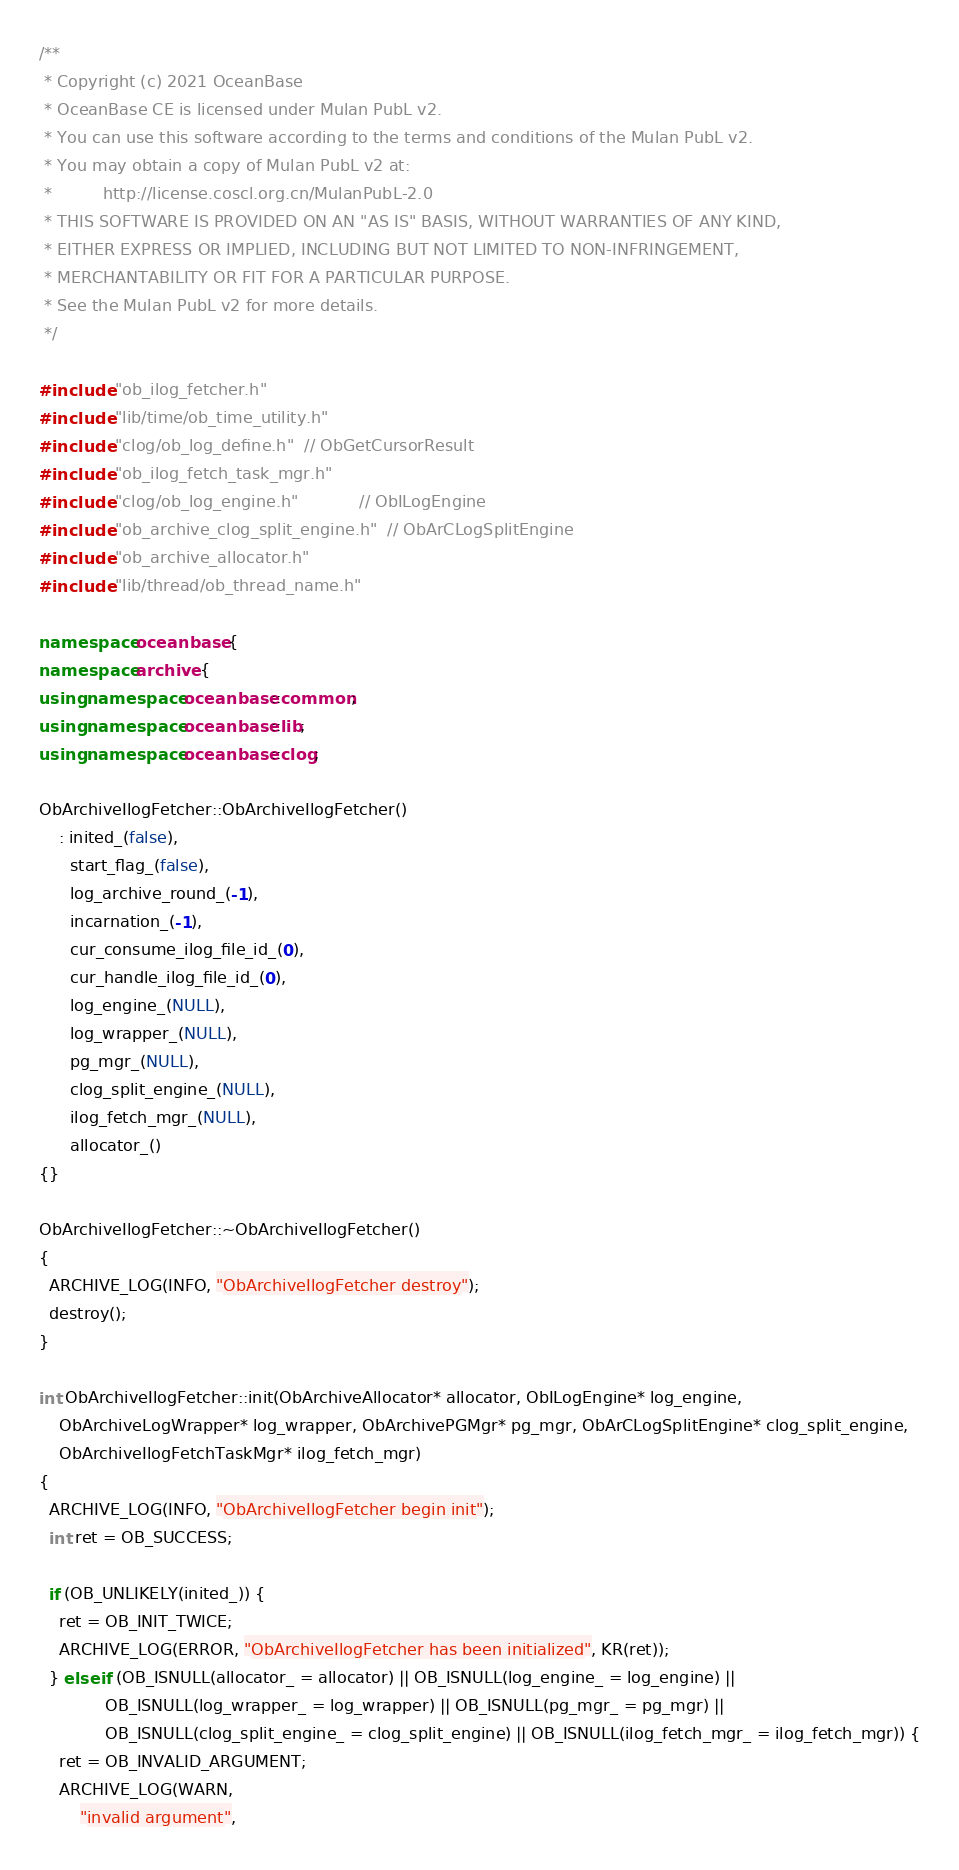Convert code to text. <code><loc_0><loc_0><loc_500><loc_500><_C++_>/**
 * Copyright (c) 2021 OceanBase
 * OceanBase CE is licensed under Mulan PubL v2.
 * You can use this software according to the terms and conditions of the Mulan PubL v2.
 * You may obtain a copy of Mulan PubL v2 at:
 *          http://license.coscl.org.cn/MulanPubL-2.0
 * THIS SOFTWARE IS PROVIDED ON AN "AS IS" BASIS, WITHOUT WARRANTIES OF ANY KIND,
 * EITHER EXPRESS OR IMPLIED, INCLUDING BUT NOT LIMITED TO NON-INFRINGEMENT,
 * MERCHANTABILITY OR FIT FOR A PARTICULAR PURPOSE.
 * See the Mulan PubL v2 for more details.
 */

#include "ob_ilog_fetcher.h"
#include "lib/time/ob_time_utility.h"
#include "clog/ob_log_define.h"  // ObGetCursorResult
#include "ob_ilog_fetch_task_mgr.h"
#include "clog/ob_log_engine.h"            // ObILogEngine
#include "ob_archive_clog_split_engine.h"  // ObArCLogSplitEngine
#include "ob_archive_allocator.h"
#include "lib/thread/ob_thread_name.h"

namespace oceanbase {
namespace archive {
using namespace oceanbase::common;
using namespace oceanbase::lib;
using namespace oceanbase::clog;

ObArchiveIlogFetcher::ObArchiveIlogFetcher()
    : inited_(false),
      start_flag_(false),
      log_archive_round_(-1),
      incarnation_(-1),
      cur_consume_ilog_file_id_(0),
      cur_handle_ilog_file_id_(0),
      log_engine_(NULL),
      log_wrapper_(NULL),
      pg_mgr_(NULL),
      clog_split_engine_(NULL),
      ilog_fetch_mgr_(NULL),
      allocator_()
{}

ObArchiveIlogFetcher::~ObArchiveIlogFetcher()
{
  ARCHIVE_LOG(INFO, "ObArchiveIlogFetcher destroy");
  destroy();
}

int ObArchiveIlogFetcher::init(ObArchiveAllocator* allocator, ObILogEngine* log_engine,
    ObArchiveLogWrapper* log_wrapper, ObArchivePGMgr* pg_mgr, ObArCLogSplitEngine* clog_split_engine,
    ObArchiveIlogFetchTaskMgr* ilog_fetch_mgr)
{
  ARCHIVE_LOG(INFO, "ObArchiveIlogFetcher begin init");
  int ret = OB_SUCCESS;

  if (OB_UNLIKELY(inited_)) {
    ret = OB_INIT_TWICE;
    ARCHIVE_LOG(ERROR, "ObArchiveIlogFetcher has been initialized", KR(ret));
  } else if (OB_ISNULL(allocator_ = allocator) || OB_ISNULL(log_engine_ = log_engine) ||
             OB_ISNULL(log_wrapper_ = log_wrapper) || OB_ISNULL(pg_mgr_ = pg_mgr) ||
             OB_ISNULL(clog_split_engine_ = clog_split_engine) || OB_ISNULL(ilog_fetch_mgr_ = ilog_fetch_mgr)) {
    ret = OB_INVALID_ARGUMENT;
    ARCHIVE_LOG(WARN,
        "invalid argument",</code> 